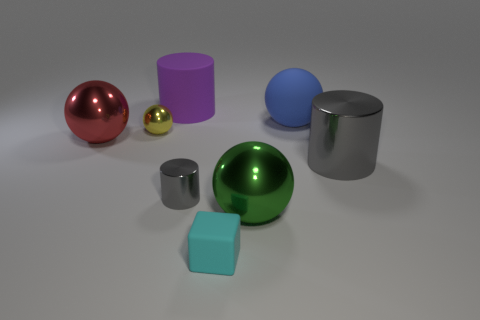What number of cylinders are behind the small gray shiny cylinder and left of the tiny rubber block?
Keep it short and to the point. 1. What number of objects are either small yellow spheres or objects that are on the right side of the big purple object?
Provide a succinct answer. 6. Is the number of small metallic things greater than the number of balls?
Your answer should be very brief. No. What shape is the rubber object that is in front of the tiny cylinder?
Keep it short and to the point. Cube. How many other things are the same shape as the big green shiny thing?
Make the answer very short. 3. What size is the red metal object that is left of the tiny cyan thing that is in front of the large blue rubber ball?
Offer a terse response. Large. How many red things are metal objects or large cylinders?
Make the answer very short. 1. Are there fewer small yellow things behind the yellow sphere than small gray things on the right side of the blue sphere?
Offer a very short reply. No. There is a red sphere; does it have the same size as the metal ball on the right side of the purple cylinder?
Your response must be concise. Yes. What number of gray shiny objects are the same size as the matte sphere?
Ensure brevity in your answer.  1. 